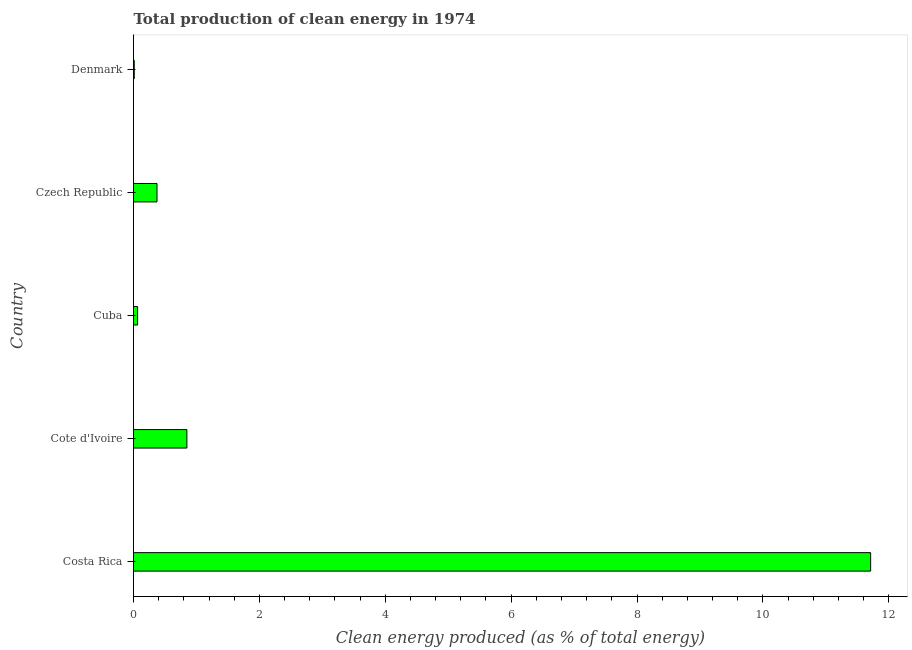Does the graph contain any zero values?
Offer a very short reply. No. Does the graph contain grids?
Offer a very short reply. No. What is the title of the graph?
Give a very brief answer. Total production of clean energy in 1974. What is the label or title of the X-axis?
Keep it short and to the point. Clean energy produced (as % of total energy). What is the production of clean energy in Cuba?
Offer a terse response. 0.07. Across all countries, what is the maximum production of clean energy?
Offer a terse response. 11.71. Across all countries, what is the minimum production of clean energy?
Your answer should be compact. 0.01. In which country was the production of clean energy maximum?
Ensure brevity in your answer.  Costa Rica. What is the sum of the production of clean energy?
Ensure brevity in your answer.  13.01. What is the difference between the production of clean energy in Cuba and Czech Republic?
Provide a succinct answer. -0.31. What is the average production of clean energy per country?
Offer a terse response. 2.6. What is the median production of clean energy?
Offer a terse response. 0.37. In how many countries, is the production of clean energy greater than 3.6 %?
Offer a very short reply. 1. What is the ratio of the production of clean energy in Cote d'Ivoire to that in Cuba?
Offer a very short reply. 13.04. What is the difference between the highest and the second highest production of clean energy?
Your answer should be very brief. 10.86. Is the sum of the production of clean energy in Costa Rica and Denmark greater than the maximum production of clean energy across all countries?
Offer a very short reply. Yes. Are all the bars in the graph horizontal?
Provide a succinct answer. Yes. How many countries are there in the graph?
Make the answer very short. 5. What is the difference between two consecutive major ticks on the X-axis?
Offer a terse response. 2. Are the values on the major ticks of X-axis written in scientific E-notation?
Give a very brief answer. No. What is the Clean energy produced (as % of total energy) in Costa Rica?
Your answer should be compact. 11.71. What is the Clean energy produced (as % of total energy) of Cote d'Ivoire?
Your answer should be very brief. 0.85. What is the Clean energy produced (as % of total energy) in Cuba?
Make the answer very short. 0.07. What is the Clean energy produced (as % of total energy) of Czech Republic?
Keep it short and to the point. 0.37. What is the Clean energy produced (as % of total energy) of Denmark?
Make the answer very short. 0.01. What is the difference between the Clean energy produced (as % of total energy) in Costa Rica and Cote d'Ivoire?
Your answer should be compact. 10.86. What is the difference between the Clean energy produced (as % of total energy) in Costa Rica and Cuba?
Give a very brief answer. 11.65. What is the difference between the Clean energy produced (as % of total energy) in Costa Rica and Czech Republic?
Offer a very short reply. 11.34. What is the difference between the Clean energy produced (as % of total energy) in Costa Rica and Denmark?
Give a very brief answer. 11.7. What is the difference between the Clean energy produced (as % of total energy) in Cote d'Ivoire and Cuba?
Provide a succinct answer. 0.78. What is the difference between the Clean energy produced (as % of total energy) in Cote d'Ivoire and Czech Republic?
Provide a succinct answer. 0.47. What is the difference between the Clean energy produced (as % of total energy) in Cote d'Ivoire and Denmark?
Give a very brief answer. 0.84. What is the difference between the Clean energy produced (as % of total energy) in Cuba and Czech Republic?
Make the answer very short. -0.31. What is the difference between the Clean energy produced (as % of total energy) in Cuba and Denmark?
Make the answer very short. 0.05. What is the difference between the Clean energy produced (as % of total energy) in Czech Republic and Denmark?
Provide a short and direct response. 0.36. What is the ratio of the Clean energy produced (as % of total energy) in Costa Rica to that in Cote d'Ivoire?
Your answer should be compact. 13.81. What is the ratio of the Clean energy produced (as % of total energy) in Costa Rica to that in Cuba?
Ensure brevity in your answer.  180.04. What is the ratio of the Clean energy produced (as % of total energy) in Costa Rica to that in Czech Republic?
Your answer should be very brief. 31.37. What is the ratio of the Clean energy produced (as % of total energy) in Costa Rica to that in Denmark?
Provide a succinct answer. 999.04. What is the ratio of the Clean energy produced (as % of total energy) in Cote d'Ivoire to that in Cuba?
Provide a succinct answer. 13.04. What is the ratio of the Clean energy produced (as % of total energy) in Cote d'Ivoire to that in Czech Republic?
Give a very brief answer. 2.27. What is the ratio of the Clean energy produced (as % of total energy) in Cote d'Ivoire to that in Denmark?
Provide a succinct answer. 72.34. What is the ratio of the Clean energy produced (as % of total energy) in Cuba to that in Czech Republic?
Keep it short and to the point. 0.17. What is the ratio of the Clean energy produced (as % of total energy) in Cuba to that in Denmark?
Ensure brevity in your answer.  5.55. What is the ratio of the Clean energy produced (as % of total energy) in Czech Republic to that in Denmark?
Your answer should be compact. 31.85. 